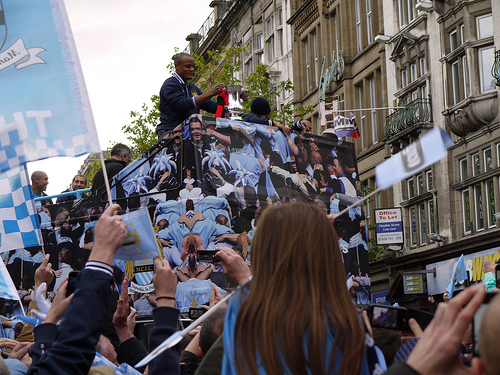<image>
Can you confirm if the man is behind the woman? Yes. From this viewpoint, the man is positioned behind the woman, with the woman partially or fully occluding the man. 